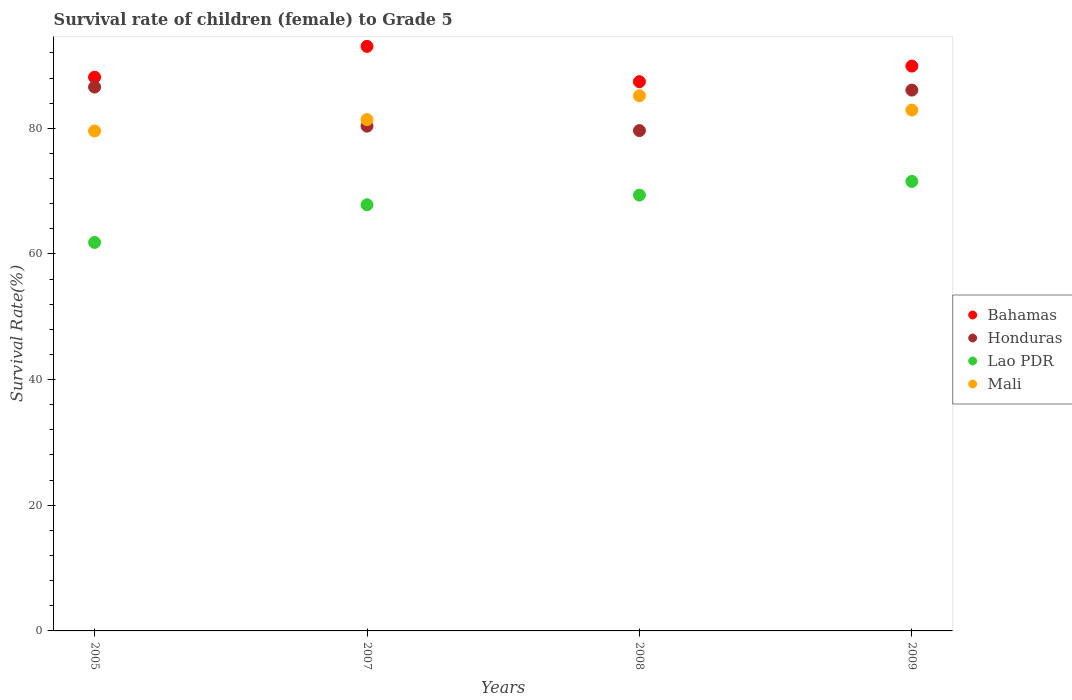What is the survival rate of female children to grade 5 in Honduras in 2009?
Ensure brevity in your answer.  86.08. Across all years, what is the maximum survival rate of female children to grade 5 in Mali?
Your response must be concise. 85.18. Across all years, what is the minimum survival rate of female children to grade 5 in Mali?
Provide a short and direct response. 79.57. What is the total survival rate of female children to grade 5 in Mali in the graph?
Your answer should be compact. 329.02. What is the difference between the survival rate of female children to grade 5 in Bahamas in 2005 and that in 2007?
Offer a very short reply. -4.9. What is the difference between the survival rate of female children to grade 5 in Lao PDR in 2007 and the survival rate of female children to grade 5 in Honduras in 2009?
Make the answer very short. -18.25. What is the average survival rate of female children to grade 5 in Mali per year?
Keep it short and to the point. 82.25. In the year 2007, what is the difference between the survival rate of female children to grade 5 in Lao PDR and survival rate of female children to grade 5 in Mali?
Offer a terse response. -13.55. What is the ratio of the survival rate of female children to grade 5 in Lao PDR in 2007 to that in 2009?
Offer a very short reply. 0.95. Is the survival rate of female children to grade 5 in Honduras in 2007 less than that in 2008?
Offer a terse response. No. What is the difference between the highest and the second highest survival rate of female children to grade 5 in Lao PDR?
Keep it short and to the point. 2.18. What is the difference between the highest and the lowest survival rate of female children to grade 5 in Honduras?
Keep it short and to the point. 6.93. In how many years, is the survival rate of female children to grade 5 in Lao PDR greater than the average survival rate of female children to grade 5 in Lao PDR taken over all years?
Provide a short and direct response. 3. Is it the case that in every year, the sum of the survival rate of female children to grade 5 in Honduras and survival rate of female children to grade 5 in Lao PDR  is greater than the sum of survival rate of female children to grade 5 in Mali and survival rate of female children to grade 5 in Bahamas?
Provide a short and direct response. No. Does the survival rate of female children to grade 5 in Mali monotonically increase over the years?
Your answer should be very brief. No. Is the survival rate of female children to grade 5 in Honduras strictly less than the survival rate of female children to grade 5 in Mali over the years?
Ensure brevity in your answer.  No. What is the difference between two consecutive major ticks on the Y-axis?
Make the answer very short. 20. Are the values on the major ticks of Y-axis written in scientific E-notation?
Your answer should be compact. No. How many legend labels are there?
Your answer should be very brief. 4. What is the title of the graph?
Your answer should be compact. Survival rate of children (female) to Grade 5. What is the label or title of the Y-axis?
Give a very brief answer. Survival Rate(%). What is the Survival Rate(%) of Bahamas in 2005?
Your response must be concise. 88.13. What is the Survival Rate(%) in Honduras in 2005?
Offer a terse response. 86.56. What is the Survival Rate(%) of Lao PDR in 2005?
Keep it short and to the point. 61.83. What is the Survival Rate(%) in Mali in 2005?
Offer a very short reply. 79.57. What is the Survival Rate(%) in Bahamas in 2007?
Your answer should be very brief. 93.03. What is the Survival Rate(%) in Honduras in 2007?
Offer a terse response. 80.34. What is the Survival Rate(%) of Lao PDR in 2007?
Make the answer very short. 67.83. What is the Survival Rate(%) in Mali in 2007?
Your answer should be compact. 81.38. What is the Survival Rate(%) in Bahamas in 2008?
Your response must be concise. 87.42. What is the Survival Rate(%) in Honduras in 2008?
Offer a very short reply. 79.63. What is the Survival Rate(%) of Lao PDR in 2008?
Your response must be concise. 69.36. What is the Survival Rate(%) in Mali in 2008?
Give a very brief answer. 85.18. What is the Survival Rate(%) in Bahamas in 2009?
Give a very brief answer. 89.9. What is the Survival Rate(%) in Honduras in 2009?
Give a very brief answer. 86.08. What is the Survival Rate(%) of Lao PDR in 2009?
Make the answer very short. 71.54. What is the Survival Rate(%) in Mali in 2009?
Offer a terse response. 82.9. Across all years, what is the maximum Survival Rate(%) in Bahamas?
Provide a short and direct response. 93.03. Across all years, what is the maximum Survival Rate(%) in Honduras?
Your response must be concise. 86.56. Across all years, what is the maximum Survival Rate(%) of Lao PDR?
Your answer should be compact. 71.54. Across all years, what is the maximum Survival Rate(%) in Mali?
Your answer should be compact. 85.18. Across all years, what is the minimum Survival Rate(%) of Bahamas?
Offer a terse response. 87.42. Across all years, what is the minimum Survival Rate(%) in Honduras?
Offer a terse response. 79.63. Across all years, what is the minimum Survival Rate(%) of Lao PDR?
Your answer should be compact. 61.83. Across all years, what is the minimum Survival Rate(%) in Mali?
Your response must be concise. 79.57. What is the total Survival Rate(%) of Bahamas in the graph?
Offer a terse response. 358.48. What is the total Survival Rate(%) of Honduras in the graph?
Ensure brevity in your answer.  332.6. What is the total Survival Rate(%) in Lao PDR in the graph?
Your response must be concise. 270.56. What is the total Survival Rate(%) in Mali in the graph?
Provide a succinct answer. 329.02. What is the difference between the Survival Rate(%) of Bahamas in 2005 and that in 2007?
Provide a succinct answer. -4.9. What is the difference between the Survival Rate(%) of Honduras in 2005 and that in 2007?
Provide a short and direct response. 6.22. What is the difference between the Survival Rate(%) in Lao PDR in 2005 and that in 2007?
Make the answer very short. -6. What is the difference between the Survival Rate(%) in Mali in 2005 and that in 2007?
Provide a short and direct response. -1.81. What is the difference between the Survival Rate(%) in Bahamas in 2005 and that in 2008?
Your answer should be very brief. 0.71. What is the difference between the Survival Rate(%) of Honduras in 2005 and that in 2008?
Ensure brevity in your answer.  6.93. What is the difference between the Survival Rate(%) of Lao PDR in 2005 and that in 2008?
Your answer should be compact. -7.53. What is the difference between the Survival Rate(%) in Mali in 2005 and that in 2008?
Keep it short and to the point. -5.61. What is the difference between the Survival Rate(%) of Bahamas in 2005 and that in 2009?
Provide a short and direct response. -1.77. What is the difference between the Survival Rate(%) of Honduras in 2005 and that in 2009?
Keep it short and to the point. 0.48. What is the difference between the Survival Rate(%) of Lao PDR in 2005 and that in 2009?
Offer a very short reply. -9.71. What is the difference between the Survival Rate(%) of Mali in 2005 and that in 2009?
Your response must be concise. -3.33. What is the difference between the Survival Rate(%) of Bahamas in 2007 and that in 2008?
Your response must be concise. 5.62. What is the difference between the Survival Rate(%) of Honduras in 2007 and that in 2008?
Your answer should be compact. 0.71. What is the difference between the Survival Rate(%) of Lao PDR in 2007 and that in 2008?
Your answer should be compact. -1.53. What is the difference between the Survival Rate(%) of Mali in 2007 and that in 2008?
Provide a short and direct response. -3.8. What is the difference between the Survival Rate(%) of Bahamas in 2007 and that in 2009?
Provide a short and direct response. 3.14. What is the difference between the Survival Rate(%) of Honduras in 2007 and that in 2009?
Your answer should be very brief. -5.74. What is the difference between the Survival Rate(%) of Lao PDR in 2007 and that in 2009?
Offer a terse response. -3.71. What is the difference between the Survival Rate(%) of Mali in 2007 and that in 2009?
Your response must be concise. -1.52. What is the difference between the Survival Rate(%) in Bahamas in 2008 and that in 2009?
Provide a succinct answer. -2.48. What is the difference between the Survival Rate(%) in Honduras in 2008 and that in 2009?
Your response must be concise. -6.44. What is the difference between the Survival Rate(%) in Lao PDR in 2008 and that in 2009?
Provide a short and direct response. -2.18. What is the difference between the Survival Rate(%) in Mali in 2008 and that in 2009?
Offer a very short reply. 2.28. What is the difference between the Survival Rate(%) of Bahamas in 2005 and the Survival Rate(%) of Honduras in 2007?
Keep it short and to the point. 7.79. What is the difference between the Survival Rate(%) in Bahamas in 2005 and the Survival Rate(%) in Lao PDR in 2007?
Your answer should be compact. 20.3. What is the difference between the Survival Rate(%) in Bahamas in 2005 and the Survival Rate(%) in Mali in 2007?
Make the answer very short. 6.75. What is the difference between the Survival Rate(%) of Honduras in 2005 and the Survival Rate(%) of Lao PDR in 2007?
Your response must be concise. 18.73. What is the difference between the Survival Rate(%) in Honduras in 2005 and the Survival Rate(%) in Mali in 2007?
Keep it short and to the point. 5.18. What is the difference between the Survival Rate(%) in Lao PDR in 2005 and the Survival Rate(%) in Mali in 2007?
Provide a succinct answer. -19.55. What is the difference between the Survival Rate(%) in Bahamas in 2005 and the Survival Rate(%) in Honduras in 2008?
Ensure brevity in your answer.  8.5. What is the difference between the Survival Rate(%) of Bahamas in 2005 and the Survival Rate(%) of Lao PDR in 2008?
Your response must be concise. 18.77. What is the difference between the Survival Rate(%) of Bahamas in 2005 and the Survival Rate(%) of Mali in 2008?
Give a very brief answer. 2.96. What is the difference between the Survival Rate(%) in Honduras in 2005 and the Survival Rate(%) in Lao PDR in 2008?
Your answer should be very brief. 17.19. What is the difference between the Survival Rate(%) in Honduras in 2005 and the Survival Rate(%) in Mali in 2008?
Offer a terse response. 1.38. What is the difference between the Survival Rate(%) in Lao PDR in 2005 and the Survival Rate(%) in Mali in 2008?
Your answer should be compact. -23.34. What is the difference between the Survival Rate(%) of Bahamas in 2005 and the Survival Rate(%) of Honduras in 2009?
Provide a succinct answer. 2.05. What is the difference between the Survival Rate(%) of Bahamas in 2005 and the Survival Rate(%) of Lao PDR in 2009?
Your answer should be compact. 16.59. What is the difference between the Survival Rate(%) of Bahamas in 2005 and the Survival Rate(%) of Mali in 2009?
Offer a very short reply. 5.24. What is the difference between the Survival Rate(%) in Honduras in 2005 and the Survival Rate(%) in Lao PDR in 2009?
Ensure brevity in your answer.  15.02. What is the difference between the Survival Rate(%) in Honduras in 2005 and the Survival Rate(%) in Mali in 2009?
Make the answer very short. 3.66. What is the difference between the Survival Rate(%) of Lao PDR in 2005 and the Survival Rate(%) of Mali in 2009?
Your answer should be compact. -21.06. What is the difference between the Survival Rate(%) in Bahamas in 2007 and the Survival Rate(%) in Honduras in 2008?
Keep it short and to the point. 13.4. What is the difference between the Survival Rate(%) in Bahamas in 2007 and the Survival Rate(%) in Lao PDR in 2008?
Offer a very short reply. 23.67. What is the difference between the Survival Rate(%) in Bahamas in 2007 and the Survival Rate(%) in Mali in 2008?
Make the answer very short. 7.86. What is the difference between the Survival Rate(%) in Honduras in 2007 and the Survival Rate(%) in Lao PDR in 2008?
Give a very brief answer. 10.97. What is the difference between the Survival Rate(%) in Honduras in 2007 and the Survival Rate(%) in Mali in 2008?
Your answer should be very brief. -4.84. What is the difference between the Survival Rate(%) of Lao PDR in 2007 and the Survival Rate(%) of Mali in 2008?
Provide a short and direct response. -17.35. What is the difference between the Survival Rate(%) in Bahamas in 2007 and the Survival Rate(%) in Honduras in 2009?
Your answer should be very brief. 6.96. What is the difference between the Survival Rate(%) in Bahamas in 2007 and the Survival Rate(%) in Lao PDR in 2009?
Ensure brevity in your answer.  21.49. What is the difference between the Survival Rate(%) in Bahamas in 2007 and the Survival Rate(%) in Mali in 2009?
Your answer should be compact. 10.14. What is the difference between the Survival Rate(%) of Honduras in 2007 and the Survival Rate(%) of Lao PDR in 2009?
Keep it short and to the point. 8.8. What is the difference between the Survival Rate(%) in Honduras in 2007 and the Survival Rate(%) in Mali in 2009?
Your response must be concise. -2.56. What is the difference between the Survival Rate(%) of Lao PDR in 2007 and the Survival Rate(%) of Mali in 2009?
Offer a very short reply. -15.07. What is the difference between the Survival Rate(%) of Bahamas in 2008 and the Survival Rate(%) of Honduras in 2009?
Ensure brevity in your answer.  1.34. What is the difference between the Survival Rate(%) in Bahamas in 2008 and the Survival Rate(%) in Lao PDR in 2009?
Your response must be concise. 15.88. What is the difference between the Survival Rate(%) in Bahamas in 2008 and the Survival Rate(%) in Mali in 2009?
Your answer should be compact. 4.52. What is the difference between the Survival Rate(%) in Honduras in 2008 and the Survival Rate(%) in Lao PDR in 2009?
Keep it short and to the point. 8.09. What is the difference between the Survival Rate(%) of Honduras in 2008 and the Survival Rate(%) of Mali in 2009?
Provide a succinct answer. -3.26. What is the difference between the Survival Rate(%) of Lao PDR in 2008 and the Survival Rate(%) of Mali in 2009?
Offer a terse response. -13.53. What is the average Survival Rate(%) in Bahamas per year?
Offer a very short reply. 89.62. What is the average Survival Rate(%) in Honduras per year?
Offer a very short reply. 83.15. What is the average Survival Rate(%) in Lao PDR per year?
Provide a succinct answer. 67.64. What is the average Survival Rate(%) in Mali per year?
Keep it short and to the point. 82.25. In the year 2005, what is the difference between the Survival Rate(%) of Bahamas and Survival Rate(%) of Honduras?
Make the answer very short. 1.57. In the year 2005, what is the difference between the Survival Rate(%) of Bahamas and Survival Rate(%) of Lao PDR?
Give a very brief answer. 26.3. In the year 2005, what is the difference between the Survival Rate(%) of Bahamas and Survival Rate(%) of Mali?
Offer a terse response. 8.56. In the year 2005, what is the difference between the Survival Rate(%) of Honduras and Survival Rate(%) of Lao PDR?
Your answer should be very brief. 24.73. In the year 2005, what is the difference between the Survival Rate(%) in Honduras and Survival Rate(%) in Mali?
Your answer should be compact. 6.99. In the year 2005, what is the difference between the Survival Rate(%) in Lao PDR and Survival Rate(%) in Mali?
Your answer should be very brief. -17.74. In the year 2007, what is the difference between the Survival Rate(%) in Bahamas and Survival Rate(%) in Honduras?
Offer a very short reply. 12.7. In the year 2007, what is the difference between the Survival Rate(%) of Bahamas and Survival Rate(%) of Lao PDR?
Your response must be concise. 25.21. In the year 2007, what is the difference between the Survival Rate(%) in Bahamas and Survival Rate(%) in Mali?
Provide a succinct answer. 11.66. In the year 2007, what is the difference between the Survival Rate(%) in Honduras and Survival Rate(%) in Lao PDR?
Make the answer very short. 12.51. In the year 2007, what is the difference between the Survival Rate(%) in Honduras and Survival Rate(%) in Mali?
Provide a short and direct response. -1.04. In the year 2007, what is the difference between the Survival Rate(%) in Lao PDR and Survival Rate(%) in Mali?
Your answer should be compact. -13.55. In the year 2008, what is the difference between the Survival Rate(%) in Bahamas and Survival Rate(%) in Honduras?
Keep it short and to the point. 7.79. In the year 2008, what is the difference between the Survival Rate(%) of Bahamas and Survival Rate(%) of Lao PDR?
Make the answer very short. 18.06. In the year 2008, what is the difference between the Survival Rate(%) in Bahamas and Survival Rate(%) in Mali?
Your response must be concise. 2.24. In the year 2008, what is the difference between the Survival Rate(%) of Honduras and Survival Rate(%) of Lao PDR?
Keep it short and to the point. 10.27. In the year 2008, what is the difference between the Survival Rate(%) in Honduras and Survival Rate(%) in Mali?
Ensure brevity in your answer.  -5.54. In the year 2008, what is the difference between the Survival Rate(%) of Lao PDR and Survival Rate(%) of Mali?
Give a very brief answer. -15.81. In the year 2009, what is the difference between the Survival Rate(%) of Bahamas and Survival Rate(%) of Honduras?
Offer a terse response. 3.82. In the year 2009, what is the difference between the Survival Rate(%) in Bahamas and Survival Rate(%) in Lao PDR?
Your response must be concise. 18.36. In the year 2009, what is the difference between the Survival Rate(%) in Bahamas and Survival Rate(%) in Mali?
Keep it short and to the point. 7. In the year 2009, what is the difference between the Survival Rate(%) of Honduras and Survival Rate(%) of Lao PDR?
Give a very brief answer. 14.54. In the year 2009, what is the difference between the Survival Rate(%) of Honduras and Survival Rate(%) of Mali?
Ensure brevity in your answer.  3.18. In the year 2009, what is the difference between the Survival Rate(%) in Lao PDR and Survival Rate(%) in Mali?
Ensure brevity in your answer.  -11.35. What is the ratio of the Survival Rate(%) of Bahamas in 2005 to that in 2007?
Provide a succinct answer. 0.95. What is the ratio of the Survival Rate(%) of Honduras in 2005 to that in 2007?
Provide a succinct answer. 1.08. What is the ratio of the Survival Rate(%) in Lao PDR in 2005 to that in 2007?
Your response must be concise. 0.91. What is the ratio of the Survival Rate(%) in Mali in 2005 to that in 2007?
Make the answer very short. 0.98. What is the ratio of the Survival Rate(%) of Honduras in 2005 to that in 2008?
Offer a terse response. 1.09. What is the ratio of the Survival Rate(%) in Lao PDR in 2005 to that in 2008?
Offer a terse response. 0.89. What is the ratio of the Survival Rate(%) in Mali in 2005 to that in 2008?
Your answer should be compact. 0.93. What is the ratio of the Survival Rate(%) of Bahamas in 2005 to that in 2009?
Your answer should be compact. 0.98. What is the ratio of the Survival Rate(%) of Honduras in 2005 to that in 2009?
Give a very brief answer. 1.01. What is the ratio of the Survival Rate(%) in Lao PDR in 2005 to that in 2009?
Ensure brevity in your answer.  0.86. What is the ratio of the Survival Rate(%) of Mali in 2005 to that in 2009?
Your response must be concise. 0.96. What is the ratio of the Survival Rate(%) in Bahamas in 2007 to that in 2008?
Provide a succinct answer. 1.06. What is the ratio of the Survival Rate(%) of Honduras in 2007 to that in 2008?
Ensure brevity in your answer.  1.01. What is the ratio of the Survival Rate(%) of Lao PDR in 2007 to that in 2008?
Ensure brevity in your answer.  0.98. What is the ratio of the Survival Rate(%) of Mali in 2007 to that in 2008?
Offer a terse response. 0.96. What is the ratio of the Survival Rate(%) in Bahamas in 2007 to that in 2009?
Offer a very short reply. 1.03. What is the ratio of the Survival Rate(%) of Honduras in 2007 to that in 2009?
Give a very brief answer. 0.93. What is the ratio of the Survival Rate(%) of Lao PDR in 2007 to that in 2009?
Ensure brevity in your answer.  0.95. What is the ratio of the Survival Rate(%) in Mali in 2007 to that in 2009?
Keep it short and to the point. 0.98. What is the ratio of the Survival Rate(%) in Bahamas in 2008 to that in 2009?
Provide a succinct answer. 0.97. What is the ratio of the Survival Rate(%) in Honduras in 2008 to that in 2009?
Provide a short and direct response. 0.93. What is the ratio of the Survival Rate(%) of Lao PDR in 2008 to that in 2009?
Keep it short and to the point. 0.97. What is the ratio of the Survival Rate(%) of Mali in 2008 to that in 2009?
Provide a succinct answer. 1.03. What is the difference between the highest and the second highest Survival Rate(%) of Bahamas?
Give a very brief answer. 3.14. What is the difference between the highest and the second highest Survival Rate(%) in Honduras?
Your response must be concise. 0.48. What is the difference between the highest and the second highest Survival Rate(%) in Lao PDR?
Your response must be concise. 2.18. What is the difference between the highest and the second highest Survival Rate(%) of Mali?
Keep it short and to the point. 2.28. What is the difference between the highest and the lowest Survival Rate(%) in Bahamas?
Your response must be concise. 5.62. What is the difference between the highest and the lowest Survival Rate(%) of Honduras?
Offer a very short reply. 6.93. What is the difference between the highest and the lowest Survival Rate(%) in Lao PDR?
Provide a succinct answer. 9.71. What is the difference between the highest and the lowest Survival Rate(%) in Mali?
Ensure brevity in your answer.  5.61. 